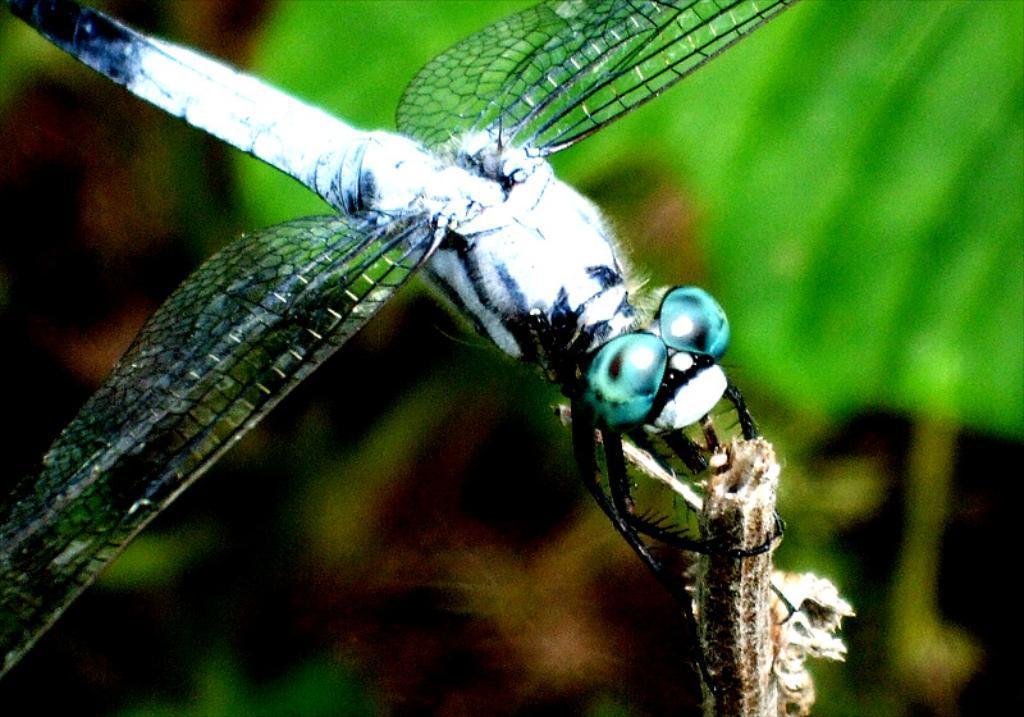Describe this image in one or two sentences. In this picture we can see an insect on a wooden object and in the background it is blurry. 